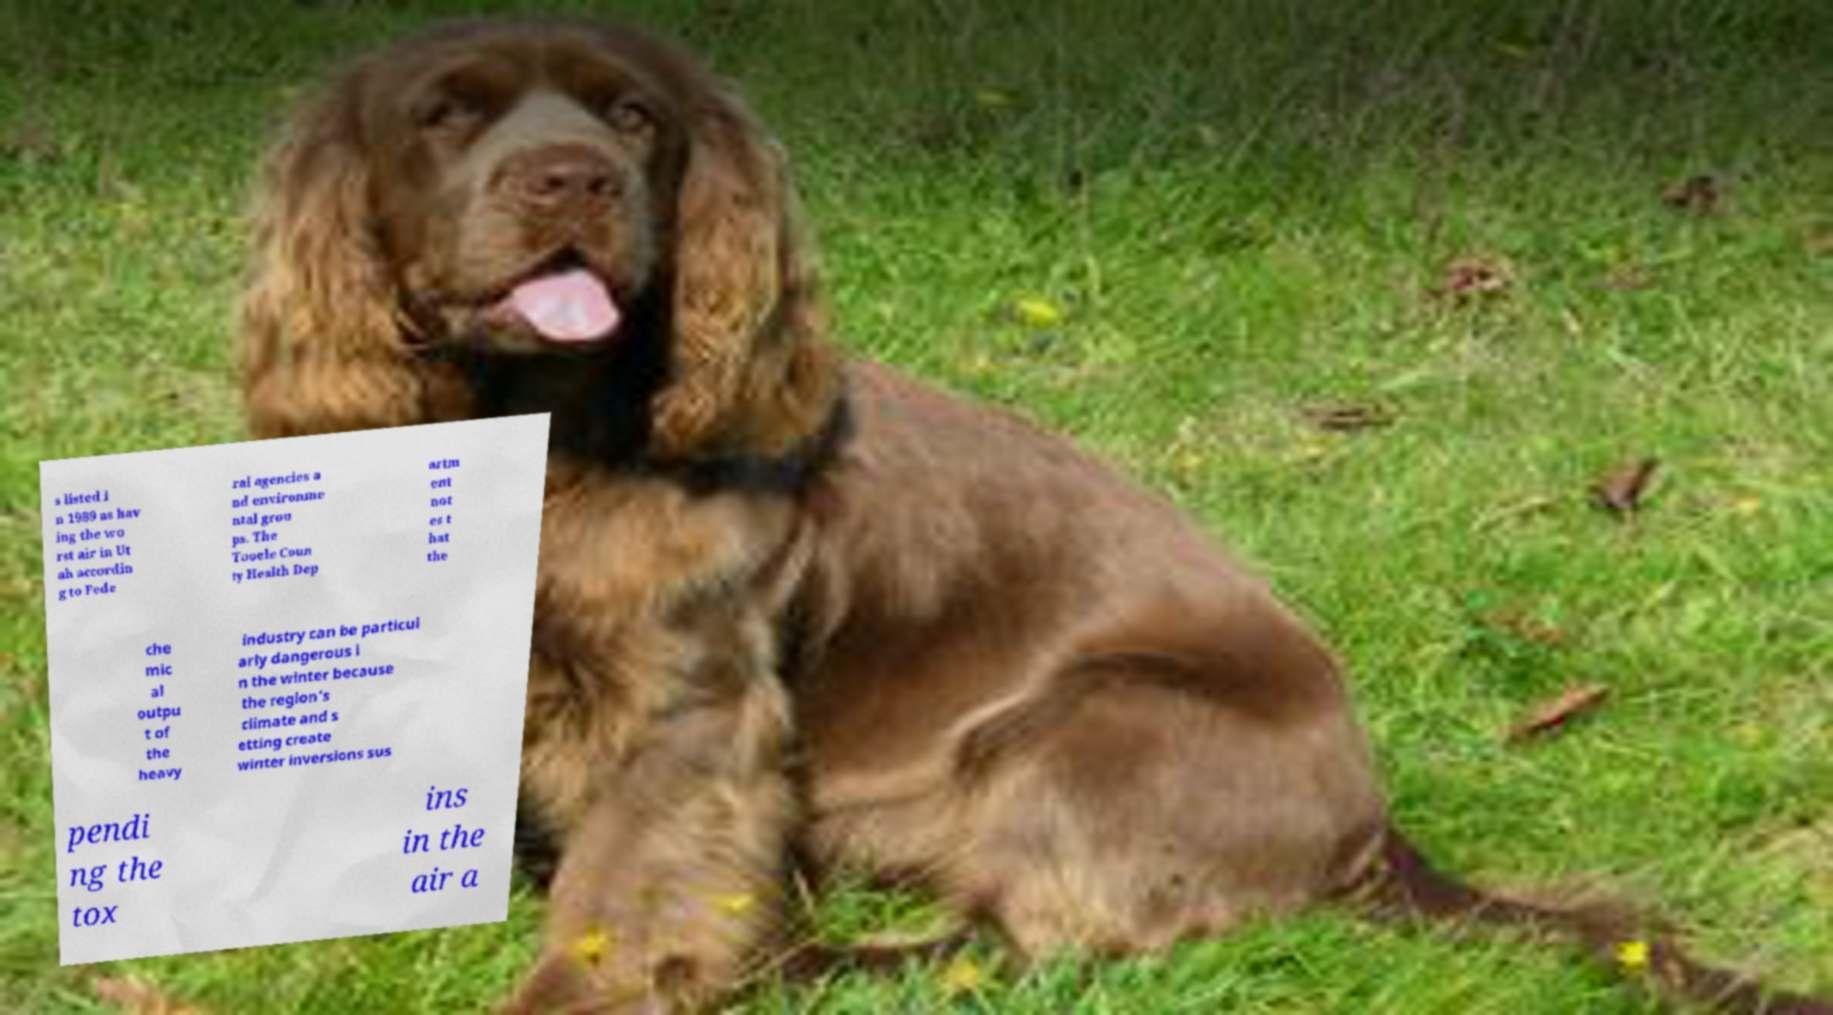Could you extract and type out the text from this image? s listed i n 1989 as hav ing the wo rst air in Ut ah accordin g to Fede ral agencies a nd environme ntal grou ps. The Tooele Coun ty Health Dep artm ent not es t hat the che mic al outpu t of the heavy industry can be particul arly dangerous i n the winter because the region's climate and s etting create winter inversions sus pendi ng the tox ins in the air a 